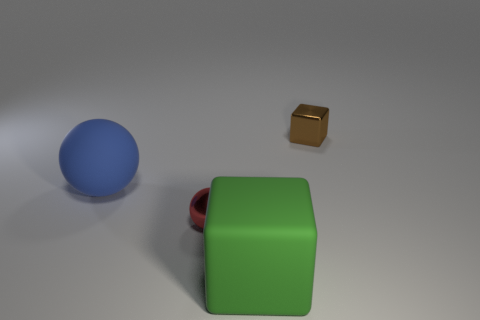Add 4 large green rubber objects. How many objects exist? 8 Subtract all brown metal cubes. Subtract all red shiny things. How many objects are left? 2 Add 3 small brown metal things. How many small brown metal things are left? 4 Add 1 small green metal blocks. How many small green metal blocks exist? 1 Subtract 0 gray cubes. How many objects are left? 4 